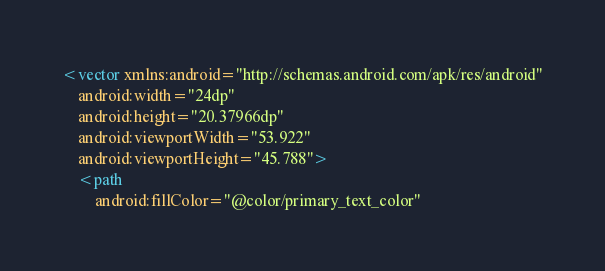Convert code to text. <code><loc_0><loc_0><loc_500><loc_500><_XML_><vector xmlns:android="http://schemas.android.com/apk/res/android"
    android:width="24dp"
    android:height="20.37966dp"
    android:viewportWidth="53.922"
    android:viewportHeight="45.788">
    <path
        android:fillColor="@color/primary_text_color"</code> 